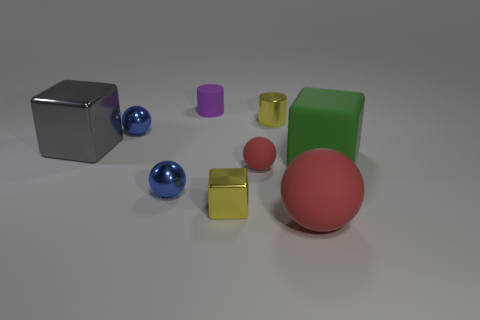What shape is the red rubber thing that is the same size as the green thing?
Your answer should be very brief. Sphere. There is a blue metallic object behind the large cube right of the large ball that is in front of the purple cylinder; what is its shape?
Ensure brevity in your answer.  Sphere. There is a rubber sphere that is right of the small metallic cylinder; is its color the same as the small rubber sphere that is in front of the matte cube?
Make the answer very short. Yes. What number of big rubber objects are there?
Give a very brief answer. 2. Are there any shiny cylinders in front of the big green matte cube?
Give a very brief answer. No. Is the material of the large block on the right side of the tiny purple rubber object the same as the large thing left of the large red sphere?
Offer a terse response. No. Is the number of tiny purple matte things in front of the big green rubber block less than the number of green things?
Keep it short and to the point. Yes. There is a metallic ball that is behind the big green matte block; what color is it?
Your answer should be very brief. Blue. There is a small sphere on the right side of the small cylinder that is on the left side of the small yellow cylinder; what is its material?
Provide a succinct answer. Rubber. Is there a red rubber ball that has the same size as the metallic cylinder?
Offer a terse response. Yes. 